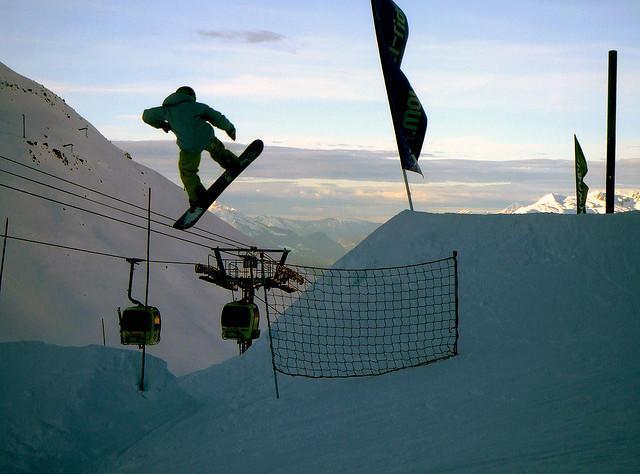How many people can you see?
Give a very brief answer. 1. 